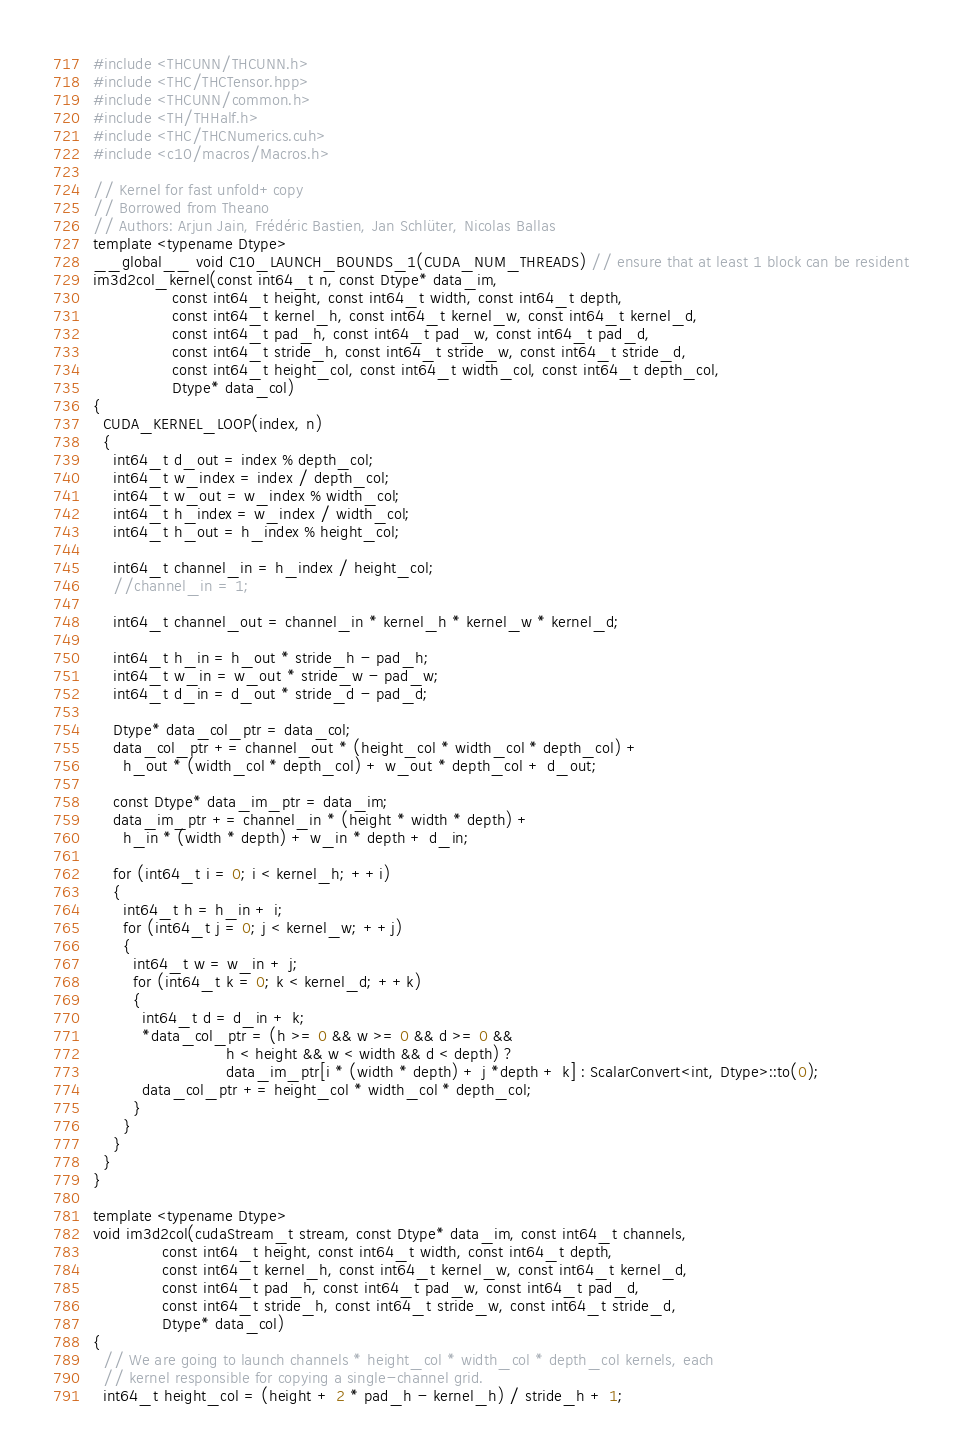<code> <loc_0><loc_0><loc_500><loc_500><_Cuda_>#include <THCUNN/THCUNN.h>
#include <THC/THCTensor.hpp>
#include <THCUNN/common.h>
#include <TH/THHalf.h>
#include <THC/THCNumerics.cuh>
#include <c10/macros/Macros.h>

// Kernel for fast unfold+copy
// Borrowed from Theano
// Authors: Arjun Jain, Frédéric Bastien, Jan Schlüter, Nicolas Ballas
template <typename Dtype>
__global__ void C10_LAUNCH_BOUNDS_1(CUDA_NUM_THREADS) // ensure that at least 1 block can be resident
im3d2col_kernel(const int64_t n, const Dtype* data_im,
                const int64_t height, const int64_t width, const int64_t depth,
                const int64_t kernel_h, const int64_t kernel_w, const int64_t kernel_d,
                const int64_t pad_h, const int64_t pad_w, const int64_t pad_d,
                const int64_t stride_h, const int64_t stride_w, const int64_t stride_d,
                const int64_t height_col, const int64_t width_col, const int64_t depth_col,
                Dtype* data_col)
{
  CUDA_KERNEL_LOOP(index, n)
  {
    int64_t d_out = index % depth_col;
    int64_t w_index = index / depth_col;
    int64_t w_out = w_index % width_col;
    int64_t h_index = w_index / width_col;
    int64_t h_out = h_index % height_col;

    int64_t channel_in = h_index / height_col;
    //channel_in = 1;

    int64_t channel_out = channel_in * kernel_h * kernel_w * kernel_d;

    int64_t h_in = h_out * stride_h - pad_h;
    int64_t w_in = w_out * stride_w - pad_w;
    int64_t d_in = d_out * stride_d - pad_d;

    Dtype* data_col_ptr = data_col;
    data_col_ptr += channel_out * (height_col * width_col * depth_col) +
      h_out * (width_col * depth_col) + w_out * depth_col + d_out;

    const Dtype* data_im_ptr = data_im;
    data_im_ptr += channel_in * (height * width * depth) +
      h_in * (width * depth) + w_in * depth + d_in;

    for (int64_t i = 0; i < kernel_h; ++i)
    {
      int64_t h = h_in + i;
      for (int64_t j = 0; j < kernel_w; ++j)
      {
        int64_t w = w_in + j;
        for (int64_t k = 0; k < kernel_d; ++k)
        {
          int64_t d = d_in + k;
          *data_col_ptr = (h >= 0 && w >= 0 && d >= 0 &&
                           h < height && w < width && d < depth) ?
                           data_im_ptr[i * (width * depth) + j *depth + k] : ScalarConvert<int, Dtype>::to(0);
          data_col_ptr += height_col * width_col * depth_col;
        }
      }
    }
  }
}

template <typename Dtype>
void im3d2col(cudaStream_t stream, const Dtype* data_im, const int64_t channels,
              const int64_t height, const int64_t width, const int64_t depth,
              const int64_t kernel_h, const int64_t kernel_w, const int64_t kernel_d,
              const int64_t pad_h, const int64_t pad_w, const int64_t pad_d,
              const int64_t stride_h, const int64_t stride_w, const int64_t stride_d,
              Dtype* data_col)
{
  // We are going to launch channels * height_col * width_col * depth_col kernels, each
  // kernel responsible for copying a single-channel grid.
  int64_t height_col = (height + 2 * pad_h - kernel_h) / stride_h + 1;</code> 